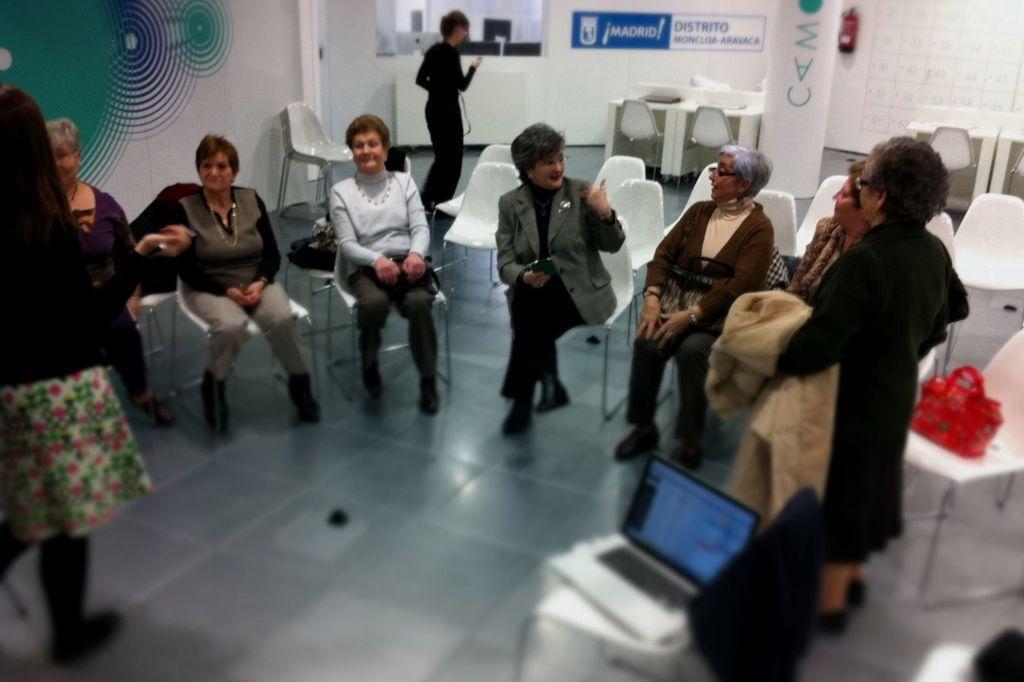In one or two sentences, can you explain what this image depicts? A group of women sitting in chairs are talking among themselves. 